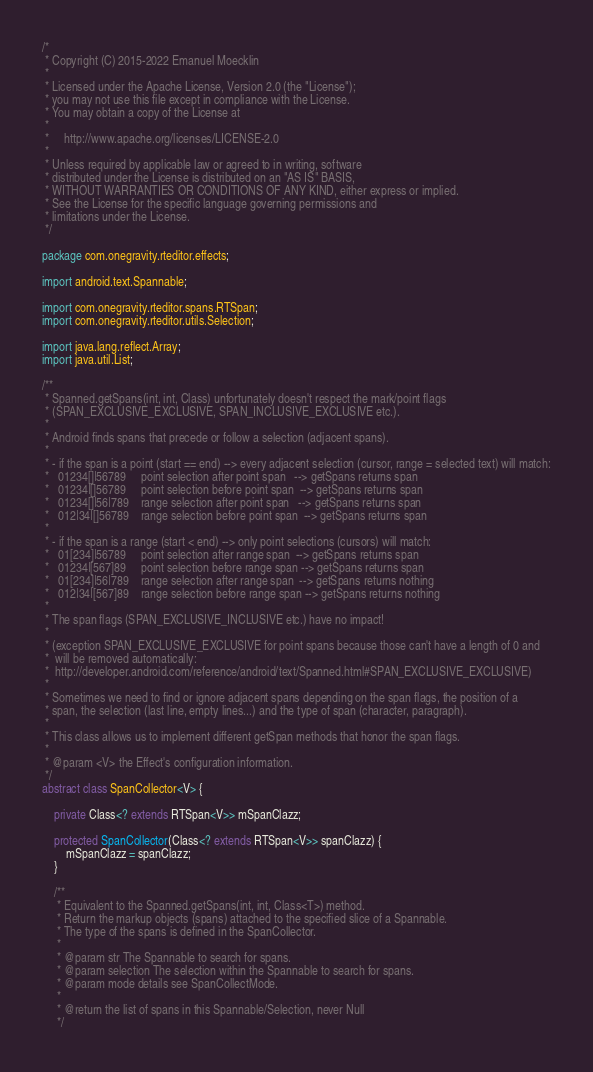<code> <loc_0><loc_0><loc_500><loc_500><_Java_>/*
 * Copyright (C) 2015-2022 Emanuel Moecklin
 *
 * Licensed under the Apache License, Version 2.0 (the "License");
 * you may not use this file except in compliance with the License.
 * You may obtain a copy of the License at
 *
 *     http://www.apache.org/licenses/LICENSE-2.0
 *
 * Unless required by applicable law or agreed to in writing, software
 * distributed under the License is distributed on an "AS IS" BASIS,
 * WITHOUT WARRANTIES OR CONDITIONS OF ANY KIND, either express or implied.
 * See the License for the specific language governing permissions and
 * limitations under the License.
 */

package com.onegravity.rteditor.effects;

import android.text.Spannable;

import com.onegravity.rteditor.spans.RTSpan;
import com.onegravity.rteditor.utils.Selection;

import java.lang.reflect.Array;
import java.util.List;

/**
 * Spanned.getSpans(int, int, Class) unfortunately doesn't respect the mark/point flags
 * (SPAN_EXCLUSIVE_EXCLUSIVE, SPAN_INCLUSIVE_EXCLUSIVE etc.).
 *
 * Android finds spans that precede or follow a selection (adjacent spans).
 *
 * - if the span is a point (start == end) --> every adjacent selection (cursor, range = selected text) will match:
 *   01234[]|56789     point selection after point span   --> getSpans returns span
 *   01234|[]56789     point selection before point span  --> getSpans returns span
 *   01234[]|56|789    range selection after point span   --> getSpans returns span
 *   012|34|[]56789    range selection before point span  --> getSpans returns span
 *
 * - if the span is a range (start < end) --> only point selections (cursors) will match:
 *   01[234]|56789     point selection after range span  --> getSpans returns span
 *   01234|[567]89     point selection before range span --> getSpans returns span
 *   01[234]|56|789    range selection after range span  --> getSpans returns nothing
 *   012|34|[567]89    range selection before range span --> getSpans returns nothing
 *
 * The span flags (SPAN_EXCLUSIVE_INCLUSIVE etc.) have no impact!
 *
 * (exception SPAN_EXCLUSIVE_EXCLUSIVE for point spans because those can't have a length of 0 and
 *  will be removed automatically:
 *  http://developer.android.com/reference/android/text/Spanned.html#SPAN_EXCLUSIVE_EXCLUSIVE)
 *
 * Sometimes we need to find or ignore adjacent spans depending on the span flags, the position of a
 * span, the selection (last line, empty lines...) and the type of span (character, paragraph).
 *
 * This class allows us to implement different getSpan methods that honor the span flags.
 *
 * @param <V> the Effect's configuration information.
 */
abstract class SpanCollector<V> {

    private Class<? extends RTSpan<V>> mSpanClazz;

    protected SpanCollector(Class<? extends RTSpan<V>> spanClazz) {
        mSpanClazz = spanClazz;
    }

    /**
     * Equivalent to the Spanned.getSpans(int, int, Class<T>) method.
     * Return the markup objects (spans) attached to the specified slice of a Spannable.
     * The type of the spans is defined in the SpanCollector.
     *
     * @param str The Spannable to search for spans.
     * @param selection The selection within the Spannable to search for spans.
     * @param mode details see SpanCollectMode.
     *
     * @return the list of spans in this Spannable/Selection, never Null
     */</code> 